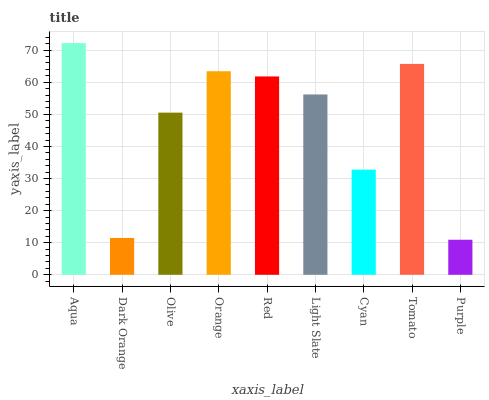Is Purple the minimum?
Answer yes or no. Yes. Is Aqua the maximum?
Answer yes or no. Yes. Is Dark Orange the minimum?
Answer yes or no. No. Is Dark Orange the maximum?
Answer yes or no. No. Is Aqua greater than Dark Orange?
Answer yes or no. Yes. Is Dark Orange less than Aqua?
Answer yes or no. Yes. Is Dark Orange greater than Aqua?
Answer yes or no. No. Is Aqua less than Dark Orange?
Answer yes or no. No. Is Light Slate the high median?
Answer yes or no. Yes. Is Light Slate the low median?
Answer yes or no. Yes. Is Purple the high median?
Answer yes or no. No. Is Tomato the low median?
Answer yes or no. No. 